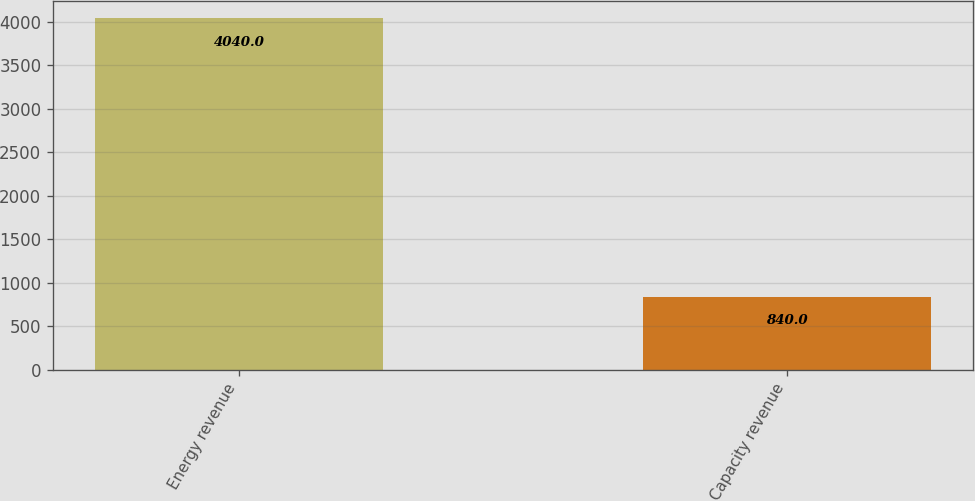Convert chart. <chart><loc_0><loc_0><loc_500><loc_500><bar_chart><fcel>Energy revenue<fcel>Capacity revenue<nl><fcel>4040<fcel>840<nl></chart> 